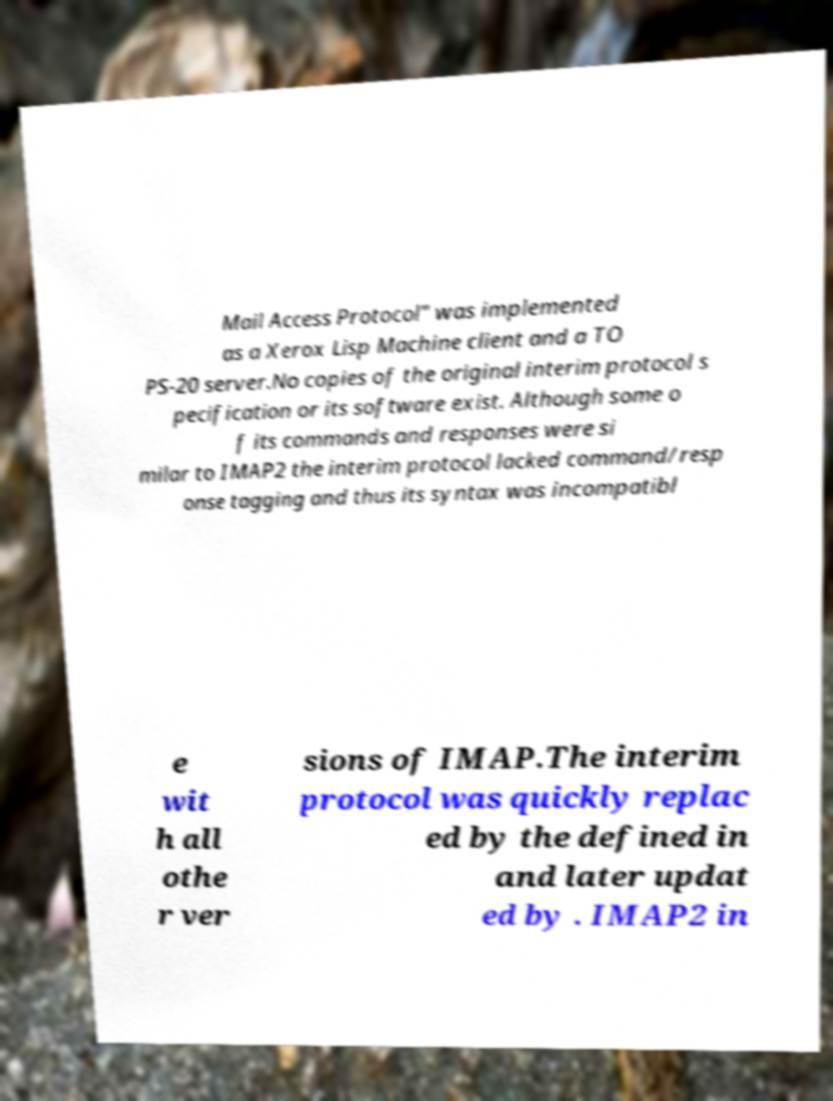Can you accurately transcribe the text from the provided image for me? Mail Access Protocol" was implemented as a Xerox Lisp Machine client and a TO PS-20 server.No copies of the original interim protocol s pecification or its software exist. Although some o f its commands and responses were si milar to IMAP2 the interim protocol lacked command/resp onse tagging and thus its syntax was incompatibl e wit h all othe r ver sions of IMAP.The interim protocol was quickly replac ed by the defined in and later updat ed by . IMAP2 in 